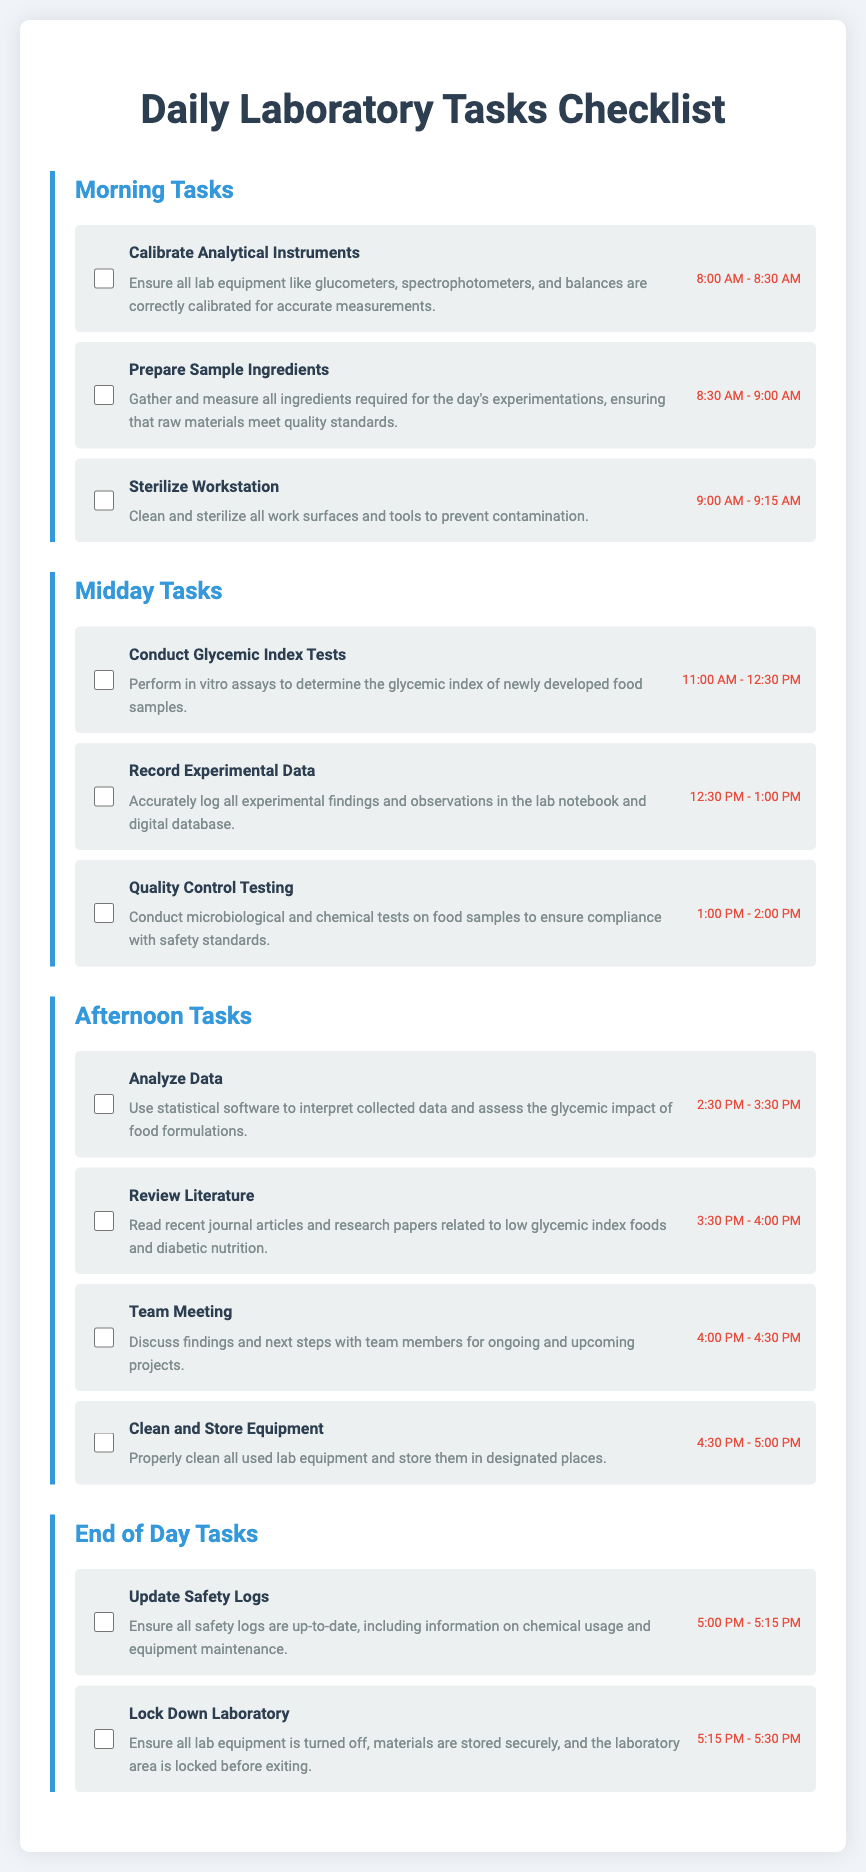What is the first task listed in the Morning Tasks? The first task listed is 'Calibrate Analytical Instruments,' which indicates the initial step for the day.
Answer: Calibrate Analytical Instruments What is the duration of the 'Conduct Glycemic Index Tests' task? The duration for this task is from 11:00 AM to 12:30 PM, indicating a 1.5-hour period dedicated to this activity.
Answer: 1.5 hours How many tasks are listed in the Afternoon Tasks section? There are four tasks listed in the Afternoon Tasks section, detailing various laboratory activities to be carried out later in the day.
Answer: 4 What is the task immediately following 'Prepare Sample Ingredients'? The task immediately following this is 'Sterilize Workstation,' which is crucial for maintaining cleanliness in the lab.
Answer: Sterilize Workstation What time is allocated for the 'Team Meeting'? The allocated time for the 'Team Meeting' task is from 4:00 PM to 4:30 PM, where team members discuss ongoing projects.
Answer: 4:00 PM - 4:30 PM What type of tests are carried out during the 'Quality Control Testing' task? This task involves conducting microbiological and chemical tests, ensuring that food samples meet safety standards.
Answer: Microbiological and chemical tests What is the last task on the checklist? The last task on the checklist is 'Lock Down Laboratory,' which involves securing the laboratory at the end of the day.
Answer: Lock Down Laboratory What is the main focus of the 'Review Literature' task? The focus is on reading recent journal articles and research papers related to low glycemic index foods and diabetic nutrition, contributing to ongoing research.
Answer: Low glycemic index foods and diabetic nutrition 